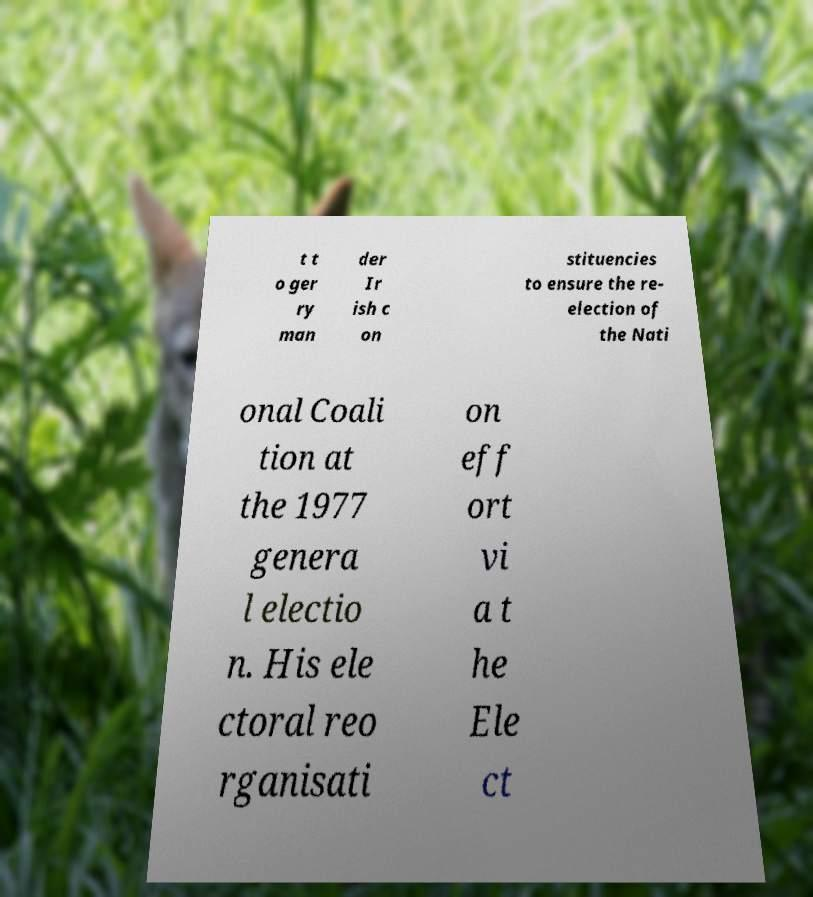What messages or text are displayed in this image? I need them in a readable, typed format. t t o ger ry man der Ir ish c on stituencies to ensure the re- election of the Nati onal Coali tion at the 1977 genera l electio n. His ele ctoral reo rganisati on eff ort vi a t he Ele ct 